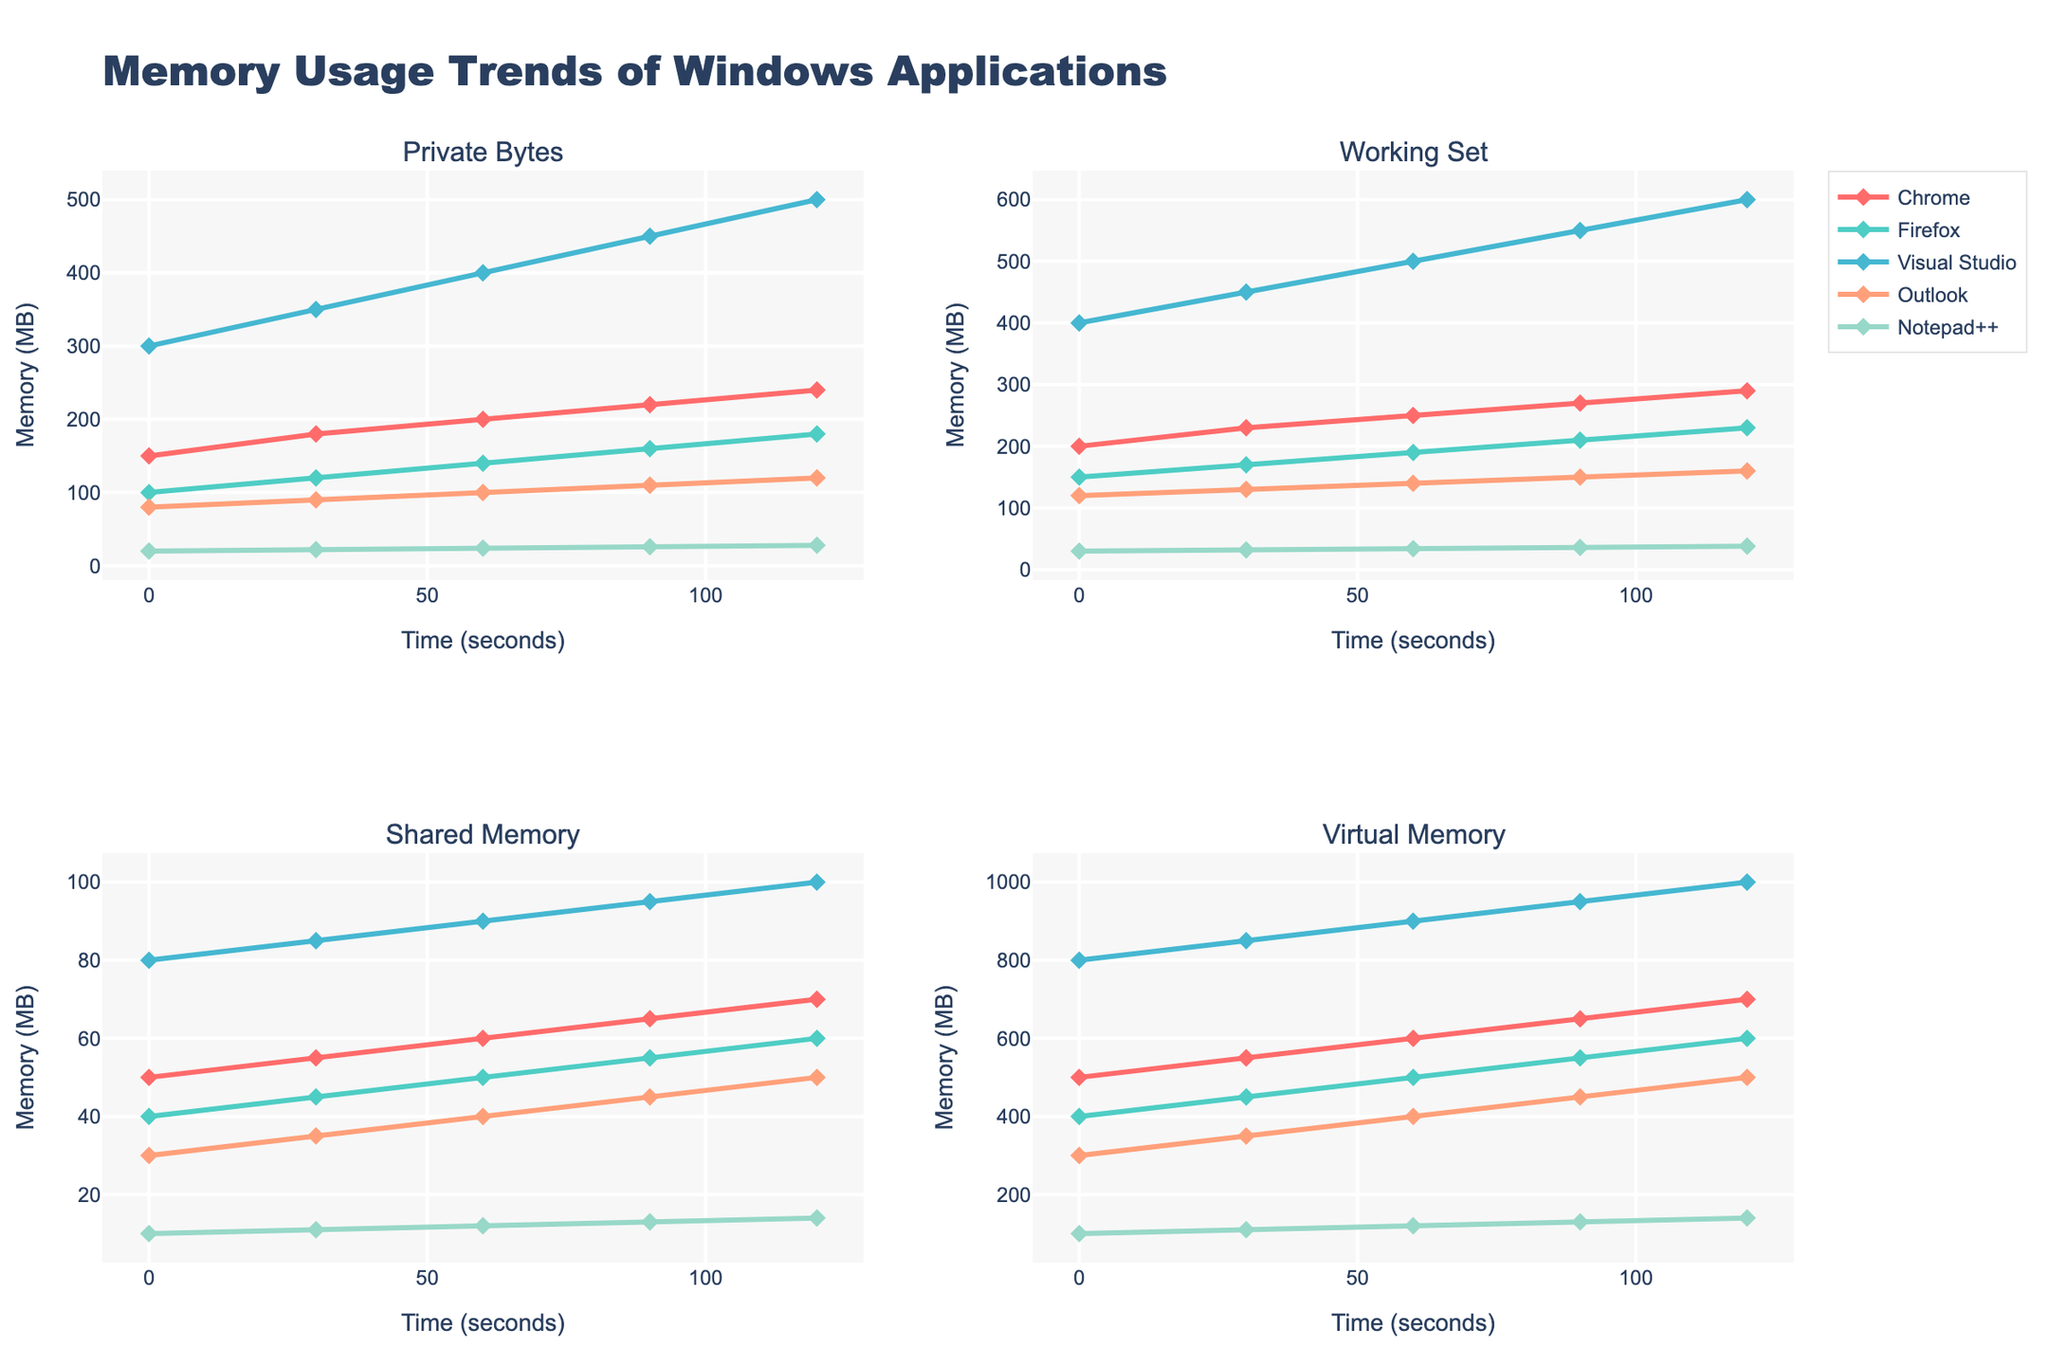Which application has the highest Private Bytes memory usage at the final timestamp? Private Bytes memory usage at the final timestamp (120 seconds) is highest for Visual Studio at 500 MB.
Answer: Visual Studio Which application shows the largest increase in Working Set memory from the start to the end? For each application, compute the change in Working Set memory from 0 to 120 seconds. The increases are: Chrome (200 -> 290 = 90 MB), Firefox (150 -> 230 = 80 MB), Visual Studio (400 -> 600 = 200 MB), Outlook (120 -> 160 = 40 MB), Notepad++ (30 -> 38 = 8 MB). Visual Studio has the largest increase.
Answer: Visual Studio How does the Shared Memory usage of Firefox compare to that of Outlook at 60 seconds? At 60 seconds, the Shared Memory usage for Firefox is 50 MB, and for Outlook, it is 40 MB. Thus, Firefox has a higher Shared Memory usage.
Answer: Firefox What is the trend in Virtual Memory usage for Notepad++? The Virtual Memory usage for Notepad++ increases gradually from 100 MB to 140 MB over the timestamps.
Answer: Increasing Which application has the most consistent memory usage in terms of Private Bytes? Checking the changes in Private Bytes, Notepad++ increases by only 2 MB every 30 seconds, showing the most consistent usage.
Answer: Notepad++ What is the average Working Set memory for Chrome across all timestamps? The Working Set memory for Chrome at each timestamp is 200, 230, 250, 270, and 290 MB. The average is (200 + 230 + 250 + 270 + 290) / 5 = 248 MB.
Answer: 248 Between Firefox and Chrome, which application uses more Shared Memory at 90 seconds? At 90 seconds, Chrome uses 65 MB, while Firefox uses 55 MB in Shared Memory. Chrome uses more.
Answer: Chrome What is the total Virtual Memory usage for all applications at 120 seconds? At 120 seconds, the Virtual Memory usages are: Chrome (700 MB), Firefox (600 MB), Visual Studio (1000 MB), Outlook (500 MB), Notepad++ (140 MB). Total = 700 + 600 + 1000 + 500 + 140 = 2940 MB.
Answer: 2940 Which application shows the steepest increase in Private Bytes between consecutive timestamps? Visual Studio shows the steepest increase in Private Bytes, with a rise of 50 MB between each timestamp from 0 to 120 seconds (e.g., 300 to 350 MB from 0 to 30 seconds).
Answer: Visual Studio 